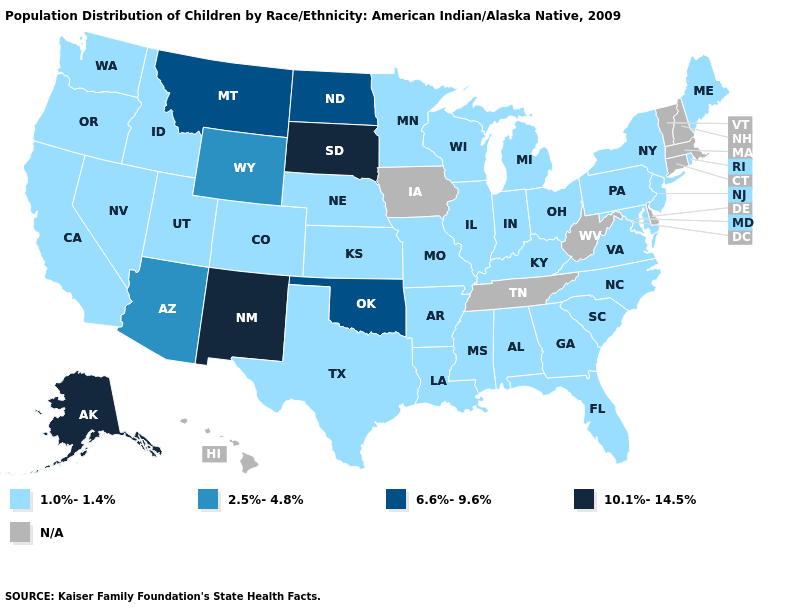What is the value of Massachusetts?
Write a very short answer. N/A. What is the lowest value in the USA?
Concise answer only. 1.0%-1.4%. Does the map have missing data?
Keep it brief. Yes. What is the lowest value in states that border Montana?
Give a very brief answer. 1.0%-1.4%. Does Oklahoma have the lowest value in the South?
Short answer required. No. Which states have the lowest value in the USA?
Write a very short answer. Alabama, Arkansas, California, Colorado, Florida, Georgia, Idaho, Illinois, Indiana, Kansas, Kentucky, Louisiana, Maine, Maryland, Michigan, Minnesota, Mississippi, Missouri, Nebraska, Nevada, New Jersey, New York, North Carolina, Ohio, Oregon, Pennsylvania, Rhode Island, South Carolina, Texas, Utah, Virginia, Washington, Wisconsin. Does Oregon have the lowest value in the West?
Answer briefly. Yes. Name the states that have a value in the range N/A?
Answer briefly. Connecticut, Delaware, Hawaii, Iowa, Massachusetts, New Hampshire, Tennessee, Vermont, West Virginia. What is the value of Maryland?
Be succinct. 1.0%-1.4%. Among the states that border Georgia , which have the lowest value?
Answer briefly. Alabama, Florida, North Carolina, South Carolina. Is the legend a continuous bar?
Be succinct. No. Which states have the lowest value in the USA?
Give a very brief answer. Alabama, Arkansas, California, Colorado, Florida, Georgia, Idaho, Illinois, Indiana, Kansas, Kentucky, Louisiana, Maine, Maryland, Michigan, Minnesota, Mississippi, Missouri, Nebraska, Nevada, New Jersey, New York, North Carolina, Ohio, Oregon, Pennsylvania, Rhode Island, South Carolina, Texas, Utah, Virginia, Washington, Wisconsin. Name the states that have a value in the range 2.5%-4.8%?
Give a very brief answer. Arizona, Wyoming. 